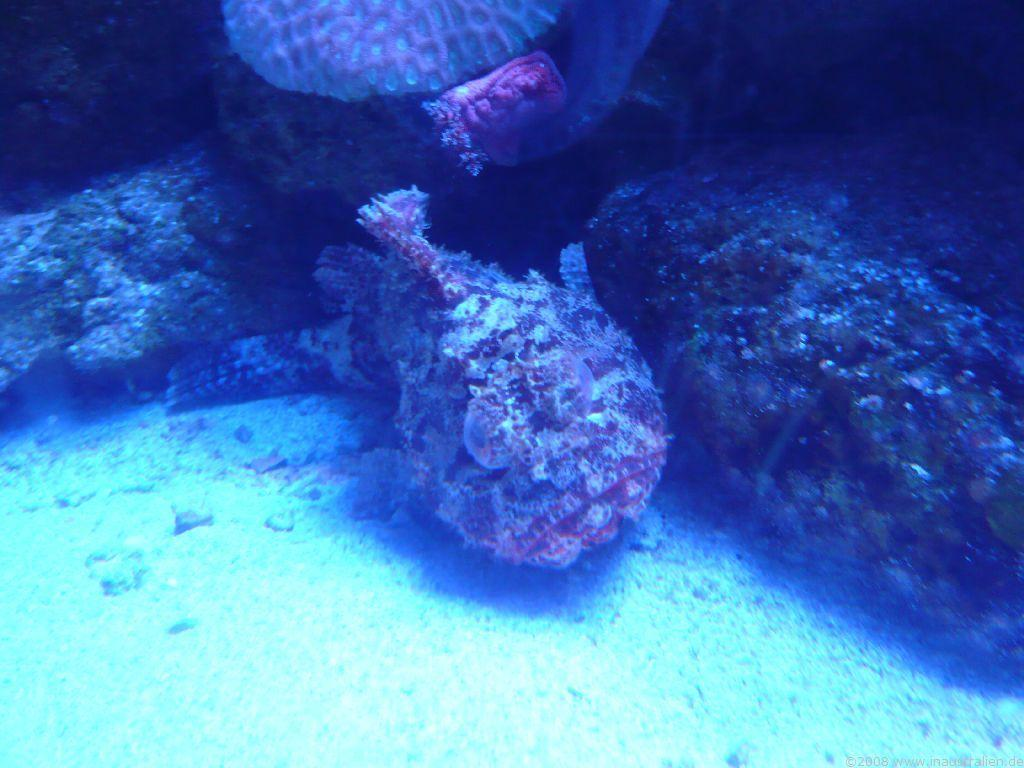What type of organisms or objects can be seen in the image? The image contains aquatic animals or plants. Can you describe the environment in which the image was taken? The image might have been taken underwater. What type of payment method is accepted by the vase in the image? There is no vase present in the image, and therefore no payment method can be associated with it. 